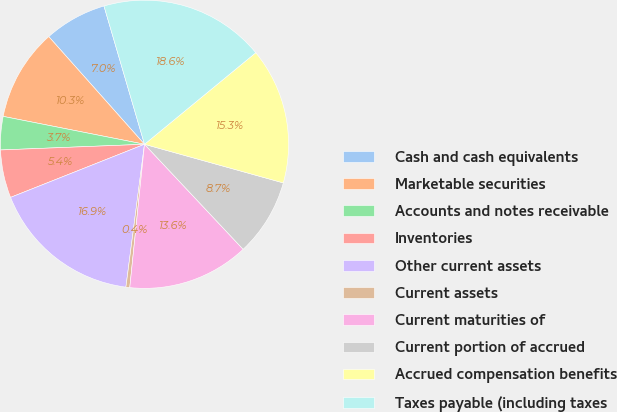Convert chart. <chart><loc_0><loc_0><loc_500><loc_500><pie_chart><fcel>Cash and cash equivalents<fcel>Marketable securities<fcel>Accounts and notes receivable<fcel>Inventories<fcel>Other current assets<fcel>Current assets<fcel>Current maturities of<fcel>Current portion of accrued<fcel>Accrued compensation benefits<fcel>Taxes payable (including taxes<nl><fcel>7.03%<fcel>10.33%<fcel>3.73%<fcel>5.38%<fcel>16.93%<fcel>0.43%<fcel>13.63%<fcel>8.68%<fcel>15.28%<fcel>18.58%<nl></chart> 